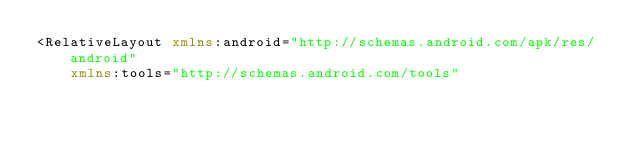<code> <loc_0><loc_0><loc_500><loc_500><_XML_><RelativeLayout xmlns:android="http://schemas.android.com/apk/res/android"
    xmlns:tools="http://schemas.android.com/tools"</code> 